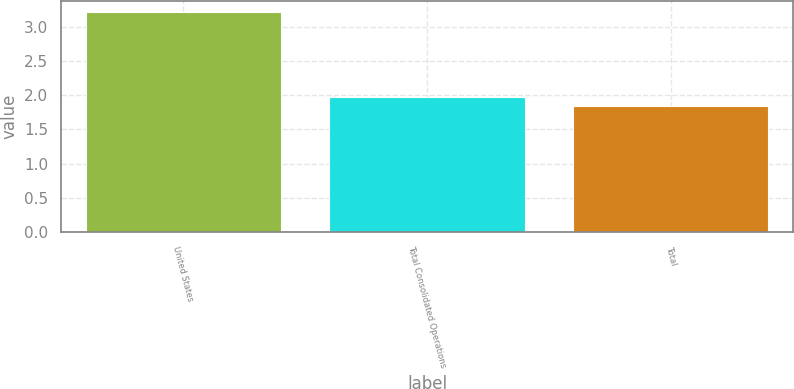Convert chart to OTSL. <chart><loc_0><loc_0><loc_500><loc_500><bar_chart><fcel>United States<fcel>Total Consolidated Operations<fcel>Total<nl><fcel>3.22<fcel>1.98<fcel>1.84<nl></chart> 